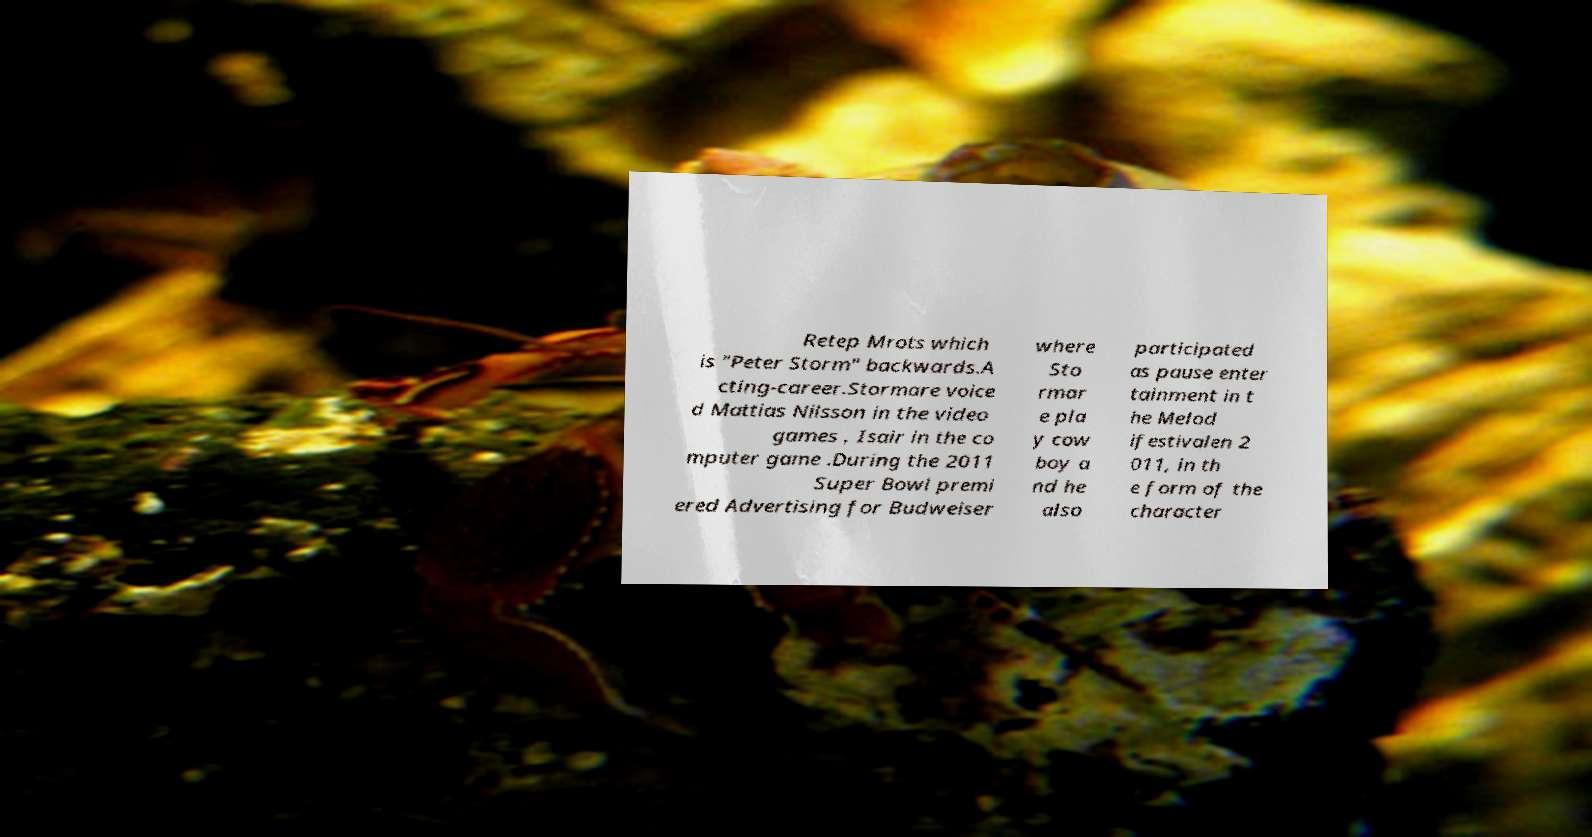Could you extract and type out the text from this image? Retep Mrots which is "Peter Storm" backwards.A cting-career.Stormare voice d Mattias Nilsson in the video games , Isair in the co mputer game .During the 2011 Super Bowl premi ered Advertising for Budweiser where Sto rmar e pla y cow boy a nd he also participated as pause enter tainment in t he Melod ifestivalen 2 011, in th e form of the character 